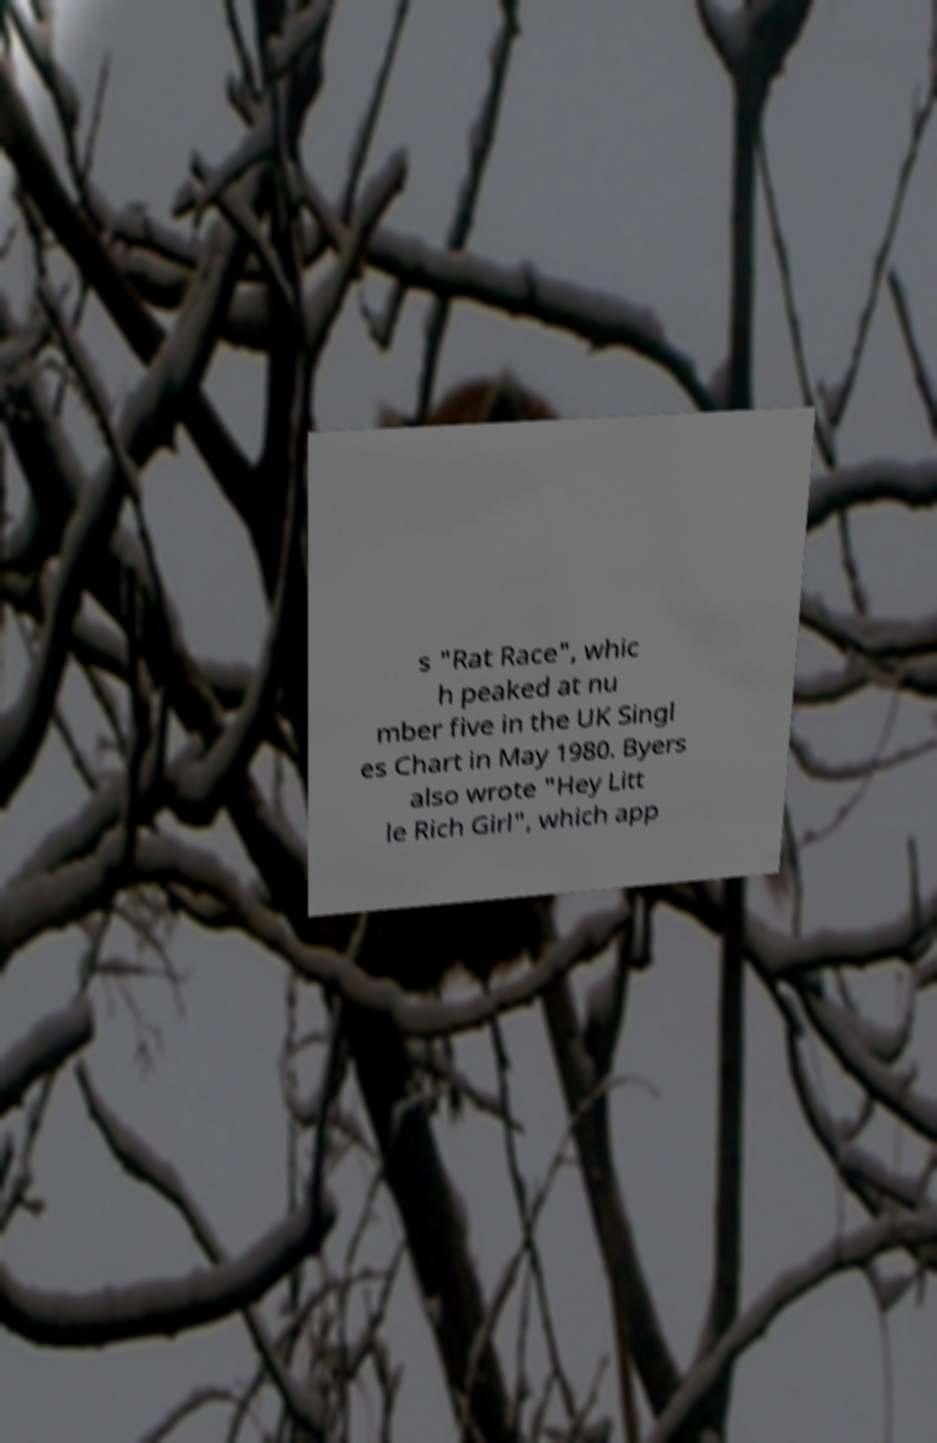For documentation purposes, I need the text within this image transcribed. Could you provide that? s "Rat Race", whic h peaked at nu mber five in the UK Singl es Chart in May 1980. Byers also wrote "Hey Litt le Rich Girl", which app 